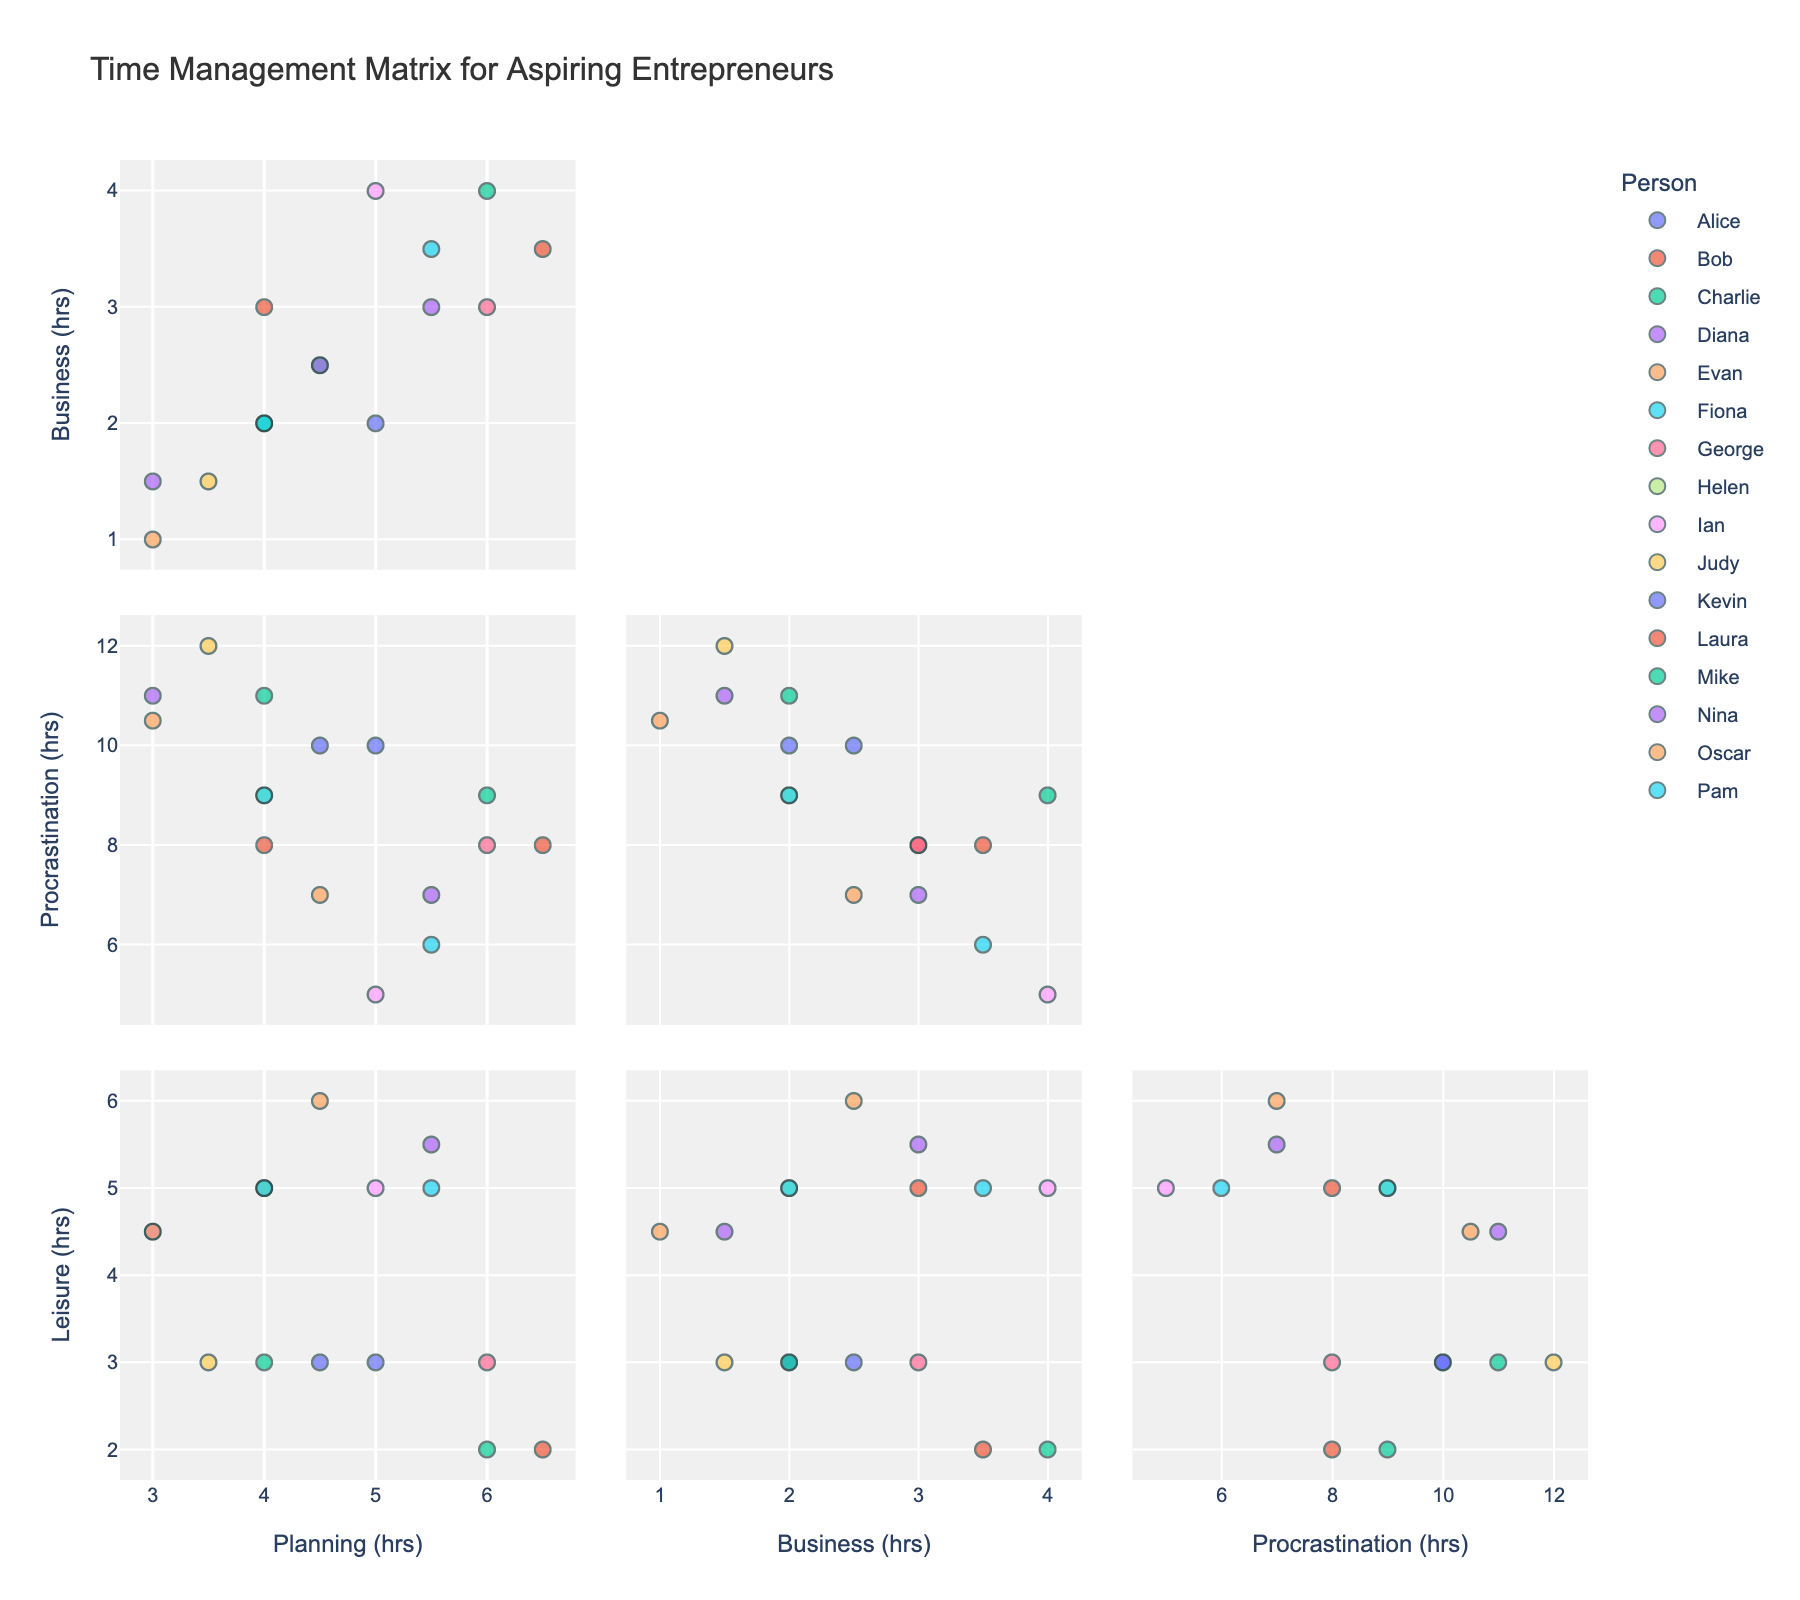What is the title of the scatter plot matrix? The title is situated at the top of the figure and gives an overview of what the SPLOM is about. It typically summarizes the theme or content depicted in the plot.
Answer: Time Management Matrix for Aspiring Entrepreneurs How many hours does Laura spend on planning? To find Laura's planning hours, locate Laura's data point in the 'Hours_Planning' axis.
Answer: 6.5 Who spends more hours on actual business activities, Bob or Kevin? Check the values for both Bob and Kevin under the 'Hours_Actual_Business' axis and compare them. Bob has 3.0 hours, and Kevin has 2.5 hours.
Answer: Bob What is the average time spent on procrastination across all individuals? Sum the procrastination hours for all individuals and divide by the number of individuals. Calculation: (10.0 + 8.0 + 9.0 + 11.0 + 7.0 + 6.0 + 8.0 + 9.0 + 5.0 + 12.0 + 10.0 + 8.0 + 11.0 + 7.0 + 10.5 + 9.0) / 16 = 8.625
Answer: 8.63 Who's data point shows the most balanced time distribution between planning, actual business, and leisure activities? Look for a data point that appears equidistant from axes for planning, business, and leisure activities. Ian spends 5.0 hrs on planning, 4.0 hrs on business, and 5.0 hrs on leisure, showing balanced time distribution.
Answer: Ian Which individual has the highest difference between hours of planning and hours of actual business? Calculate the absolute difference for each individual and find the highest. Laura has the highest difference:
Answer: Laura Is there a clear correlation between hours spent on procrastination and leisure activities? Observe the scatter points between the axes of 'Hours_Procrastination' and 'Hours_Leisure'. If there is a diagonal trend, a correlation exists.
Answer: No clear correlation Which two individuals spend the most similar amount of time on leisure activities? Compare the leisure hours and find individuals with the closest values. Helen and Pam both spend 5.0 hours on leisure activities.
Answer: Helen and Pam Who spends the least amount of time on actual business activities? Find the individual with the lowest value on the 'Hours_Actual_Business' axis. Oscar spends the least with 1.0 hr.
Answer: Oscar What is the range of hours spent on planning by these individuals? Subtract the smallest planning hour value from the largest one. Range = 6.5 hrs (Laura) − 3.0 hrs (Oscar) = 3.5 hrs.
Answer: 3.5 hrs 